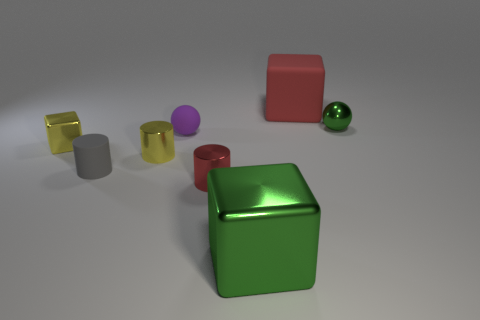Add 1 green shiny objects. How many objects exist? 9 Subtract all cylinders. How many objects are left? 5 Subtract 1 yellow cylinders. How many objects are left? 7 Subtract all blue matte blocks. Subtract all large objects. How many objects are left? 6 Add 8 metallic cubes. How many metallic cubes are left? 10 Add 4 green shiny things. How many green shiny things exist? 6 